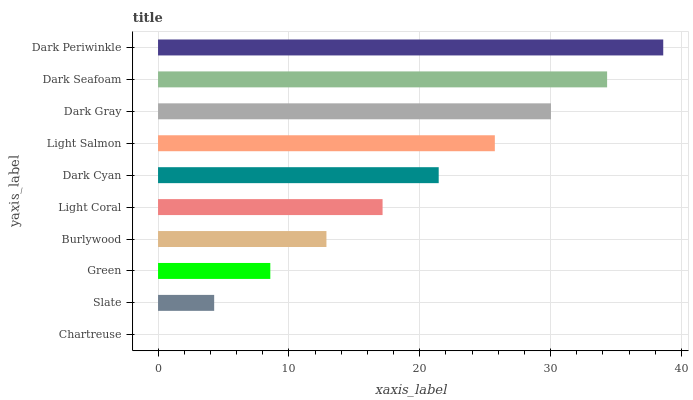Is Chartreuse the minimum?
Answer yes or no. Yes. Is Dark Periwinkle the maximum?
Answer yes or no. Yes. Is Slate the minimum?
Answer yes or no. No. Is Slate the maximum?
Answer yes or no. No. Is Slate greater than Chartreuse?
Answer yes or no. Yes. Is Chartreuse less than Slate?
Answer yes or no. Yes. Is Chartreuse greater than Slate?
Answer yes or no. No. Is Slate less than Chartreuse?
Answer yes or no. No. Is Dark Cyan the high median?
Answer yes or no. Yes. Is Light Coral the low median?
Answer yes or no. Yes. Is Green the high median?
Answer yes or no. No. Is Chartreuse the low median?
Answer yes or no. No. 